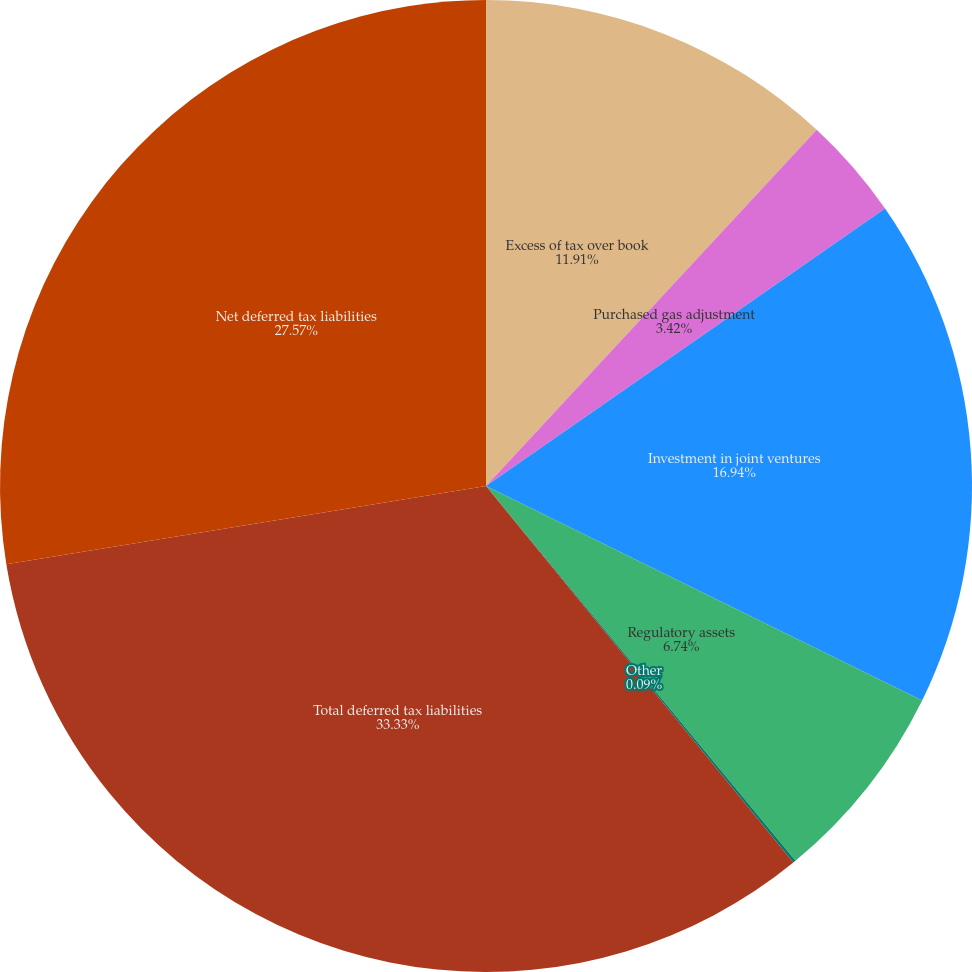Convert chart. <chart><loc_0><loc_0><loc_500><loc_500><pie_chart><fcel>Excess of tax over book<fcel>Purchased gas adjustment<fcel>Investment in joint ventures<fcel>Regulatory assets<fcel>Other<fcel>Total deferred tax liabilities<fcel>Net deferred tax liabilities<nl><fcel>11.91%<fcel>3.42%<fcel>16.94%<fcel>6.74%<fcel>0.09%<fcel>33.32%<fcel>27.57%<nl></chart> 